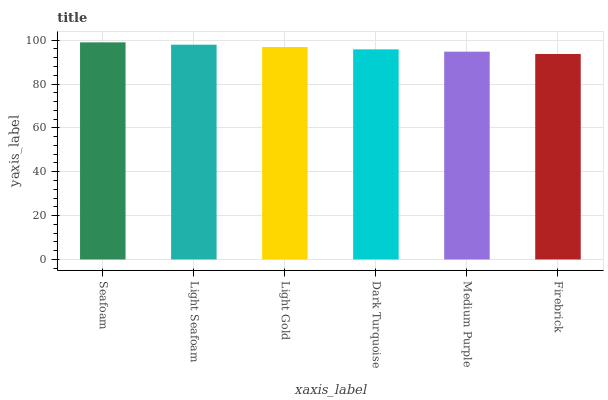Is Firebrick the minimum?
Answer yes or no. Yes. Is Seafoam the maximum?
Answer yes or no. Yes. Is Light Seafoam the minimum?
Answer yes or no. No. Is Light Seafoam the maximum?
Answer yes or no. No. Is Seafoam greater than Light Seafoam?
Answer yes or no. Yes. Is Light Seafoam less than Seafoam?
Answer yes or no. Yes. Is Light Seafoam greater than Seafoam?
Answer yes or no. No. Is Seafoam less than Light Seafoam?
Answer yes or no. No. Is Light Gold the high median?
Answer yes or no. Yes. Is Dark Turquoise the low median?
Answer yes or no. Yes. Is Seafoam the high median?
Answer yes or no. No. Is Medium Purple the low median?
Answer yes or no. No. 